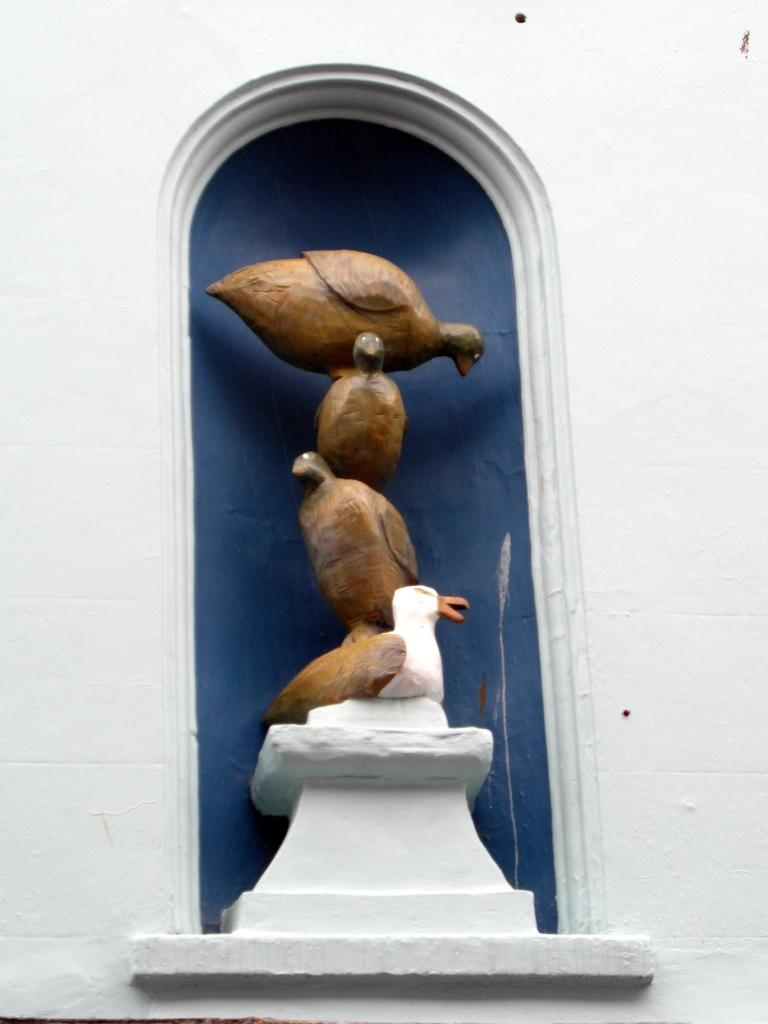What is the main subject of the image? The main subject of the image is a statue of birds. How are the birds positioned in the statue? The birds are standing one above the other in the statue. What is located above the statue in the image? There is a wall above the statue. What is the color of the background in the image? The background color is blue. How many pies are being served at the house in the image? There is no house or pies present in the image; it features a statue of birds with a wall in the background. 